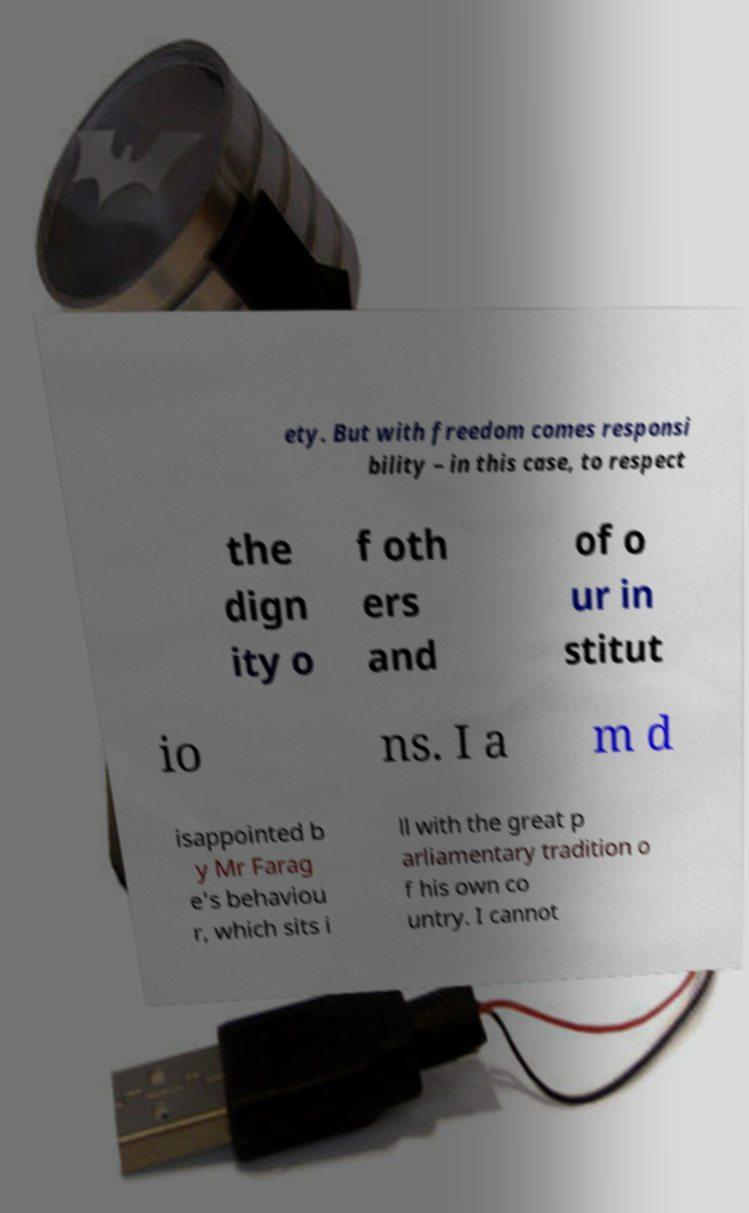Can you accurately transcribe the text from the provided image for me? ety. But with freedom comes responsi bility – in this case, to respect the dign ity o f oth ers and of o ur in stitut io ns. I a m d isappointed b y Mr Farag e's behaviou r, which sits i ll with the great p arliamentary tradition o f his own co untry. I cannot 